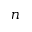Convert formula to latex. <formula><loc_0><loc_0><loc_500><loc_500>n</formula> 